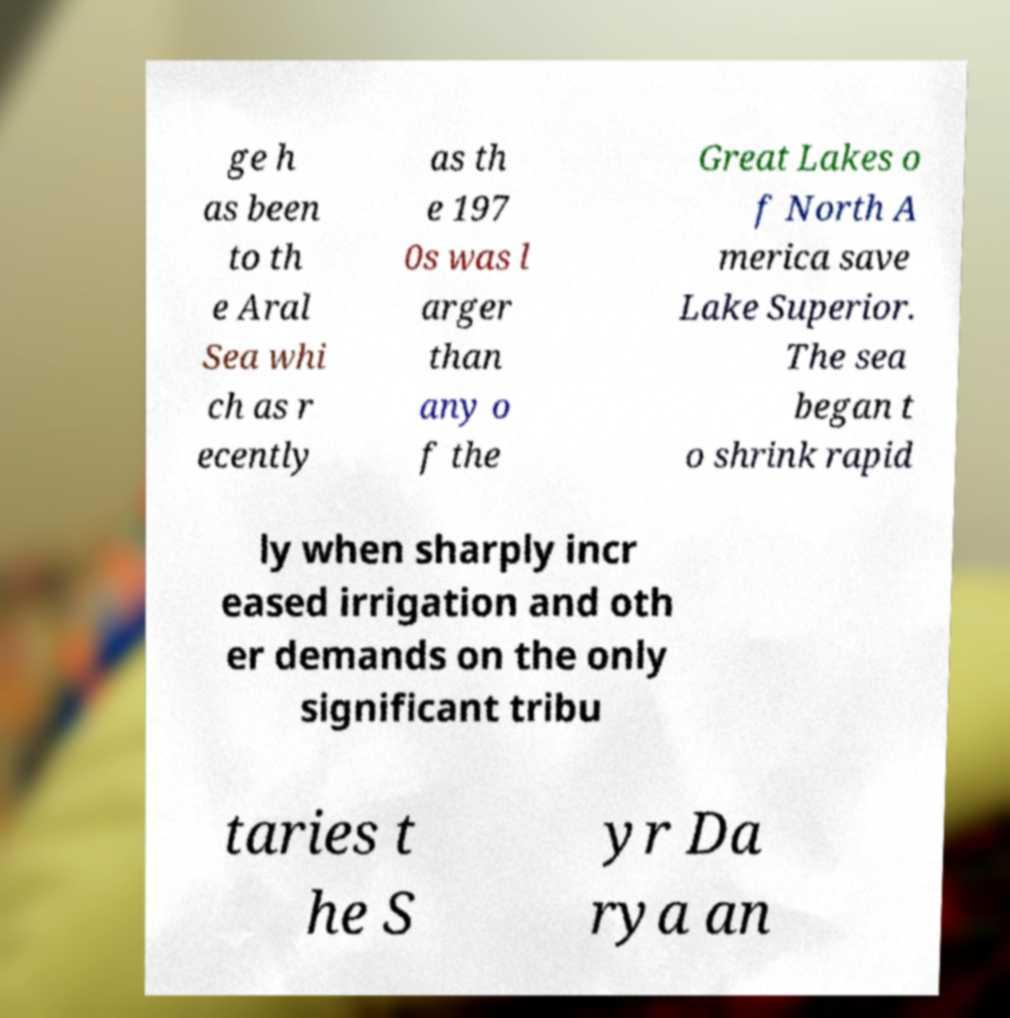Please identify and transcribe the text found in this image. ge h as been to th e Aral Sea whi ch as r ecently as th e 197 0s was l arger than any o f the Great Lakes o f North A merica save Lake Superior. The sea began t o shrink rapid ly when sharply incr eased irrigation and oth er demands on the only significant tribu taries t he S yr Da rya an 